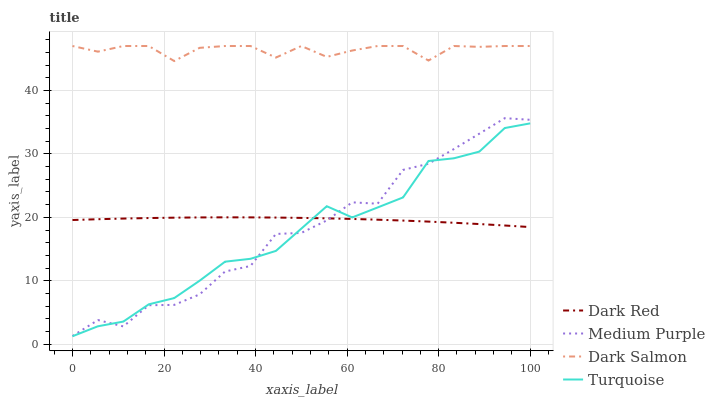Does Turquoise have the minimum area under the curve?
Answer yes or no. Yes. Does Dark Salmon have the maximum area under the curve?
Answer yes or no. Yes. Does Dark Red have the minimum area under the curve?
Answer yes or no. No. Does Dark Red have the maximum area under the curve?
Answer yes or no. No. Is Dark Red the smoothest?
Answer yes or no. Yes. Is Medium Purple the roughest?
Answer yes or no. Yes. Is Turquoise the smoothest?
Answer yes or no. No. Is Turquoise the roughest?
Answer yes or no. No. Does Turquoise have the lowest value?
Answer yes or no. Yes. Does Dark Red have the lowest value?
Answer yes or no. No. Does Dark Salmon have the highest value?
Answer yes or no. Yes. Does Turquoise have the highest value?
Answer yes or no. No. Is Dark Red less than Dark Salmon?
Answer yes or no. Yes. Is Dark Salmon greater than Medium Purple?
Answer yes or no. Yes. Does Medium Purple intersect Dark Red?
Answer yes or no. Yes. Is Medium Purple less than Dark Red?
Answer yes or no. No. Is Medium Purple greater than Dark Red?
Answer yes or no. No. Does Dark Red intersect Dark Salmon?
Answer yes or no. No. 